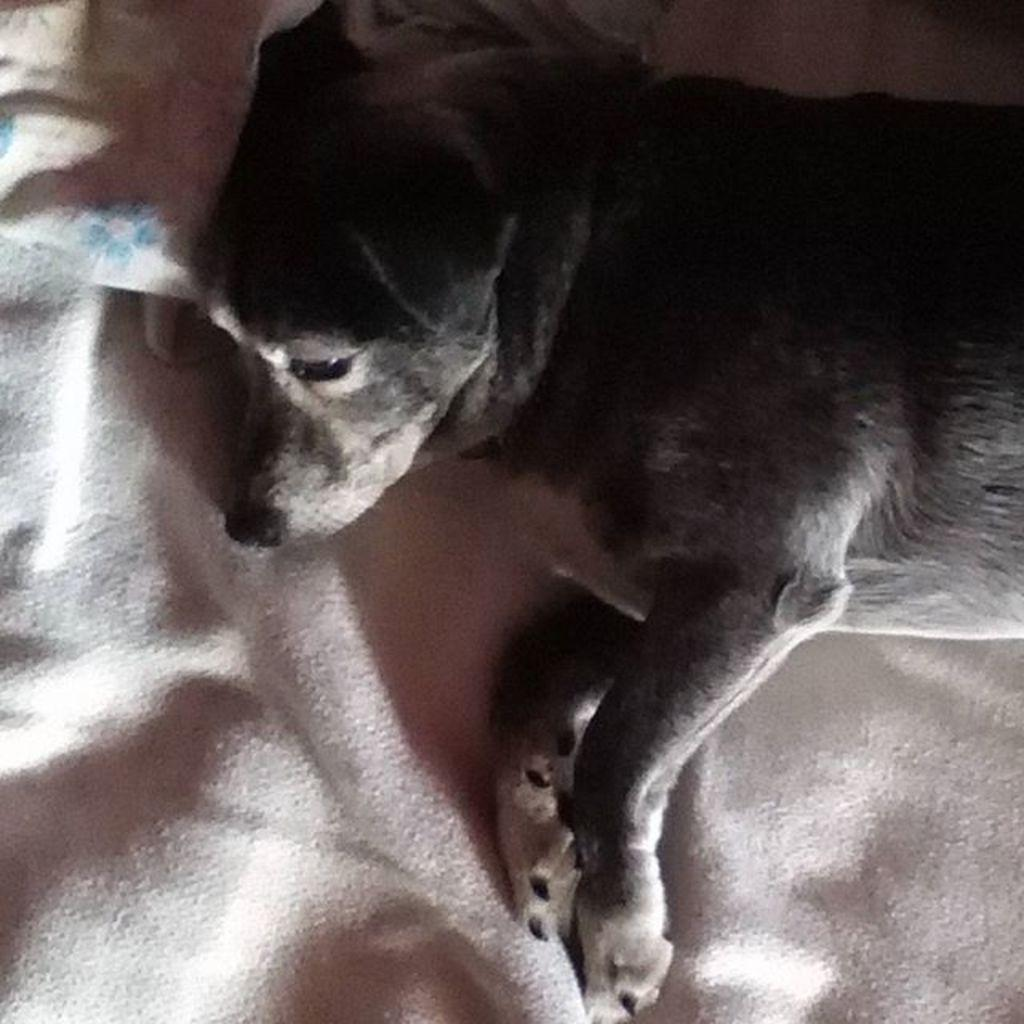What animal can be seen in the image? There is a dog in the image. What is the dog doing in the image? The dog is sleeping. Where is the dog located in the image? The dog is on a bed. What is supporting the dog's head in the image? There is a pillow below the dog's head. What type of flower can be seen growing near the lake in the image? There is no flower or lake present in the image; it features a dog sleeping on a bed. 